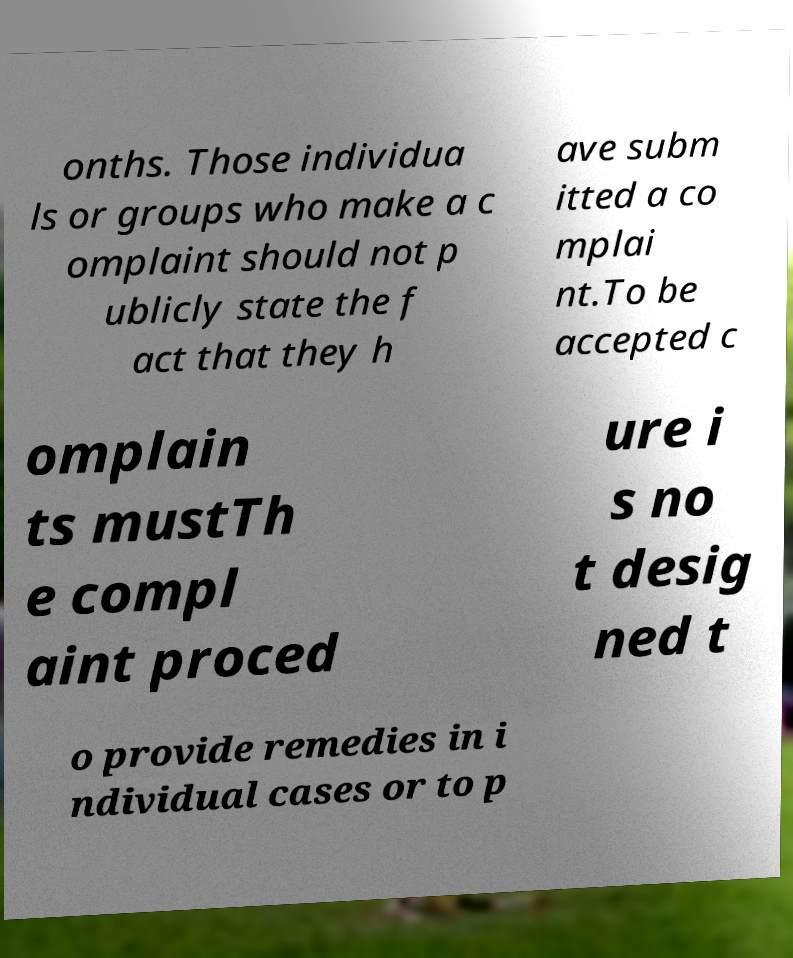Please read and relay the text visible in this image. What does it say? onths. Those individua ls or groups who make a c omplaint should not p ublicly state the f act that they h ave subm itted a co mplai nt.To be accepted c omplain ts mustTh e compl aint proced ure i s no t desig ned t o provide remedies in i ndividual cases or to p 